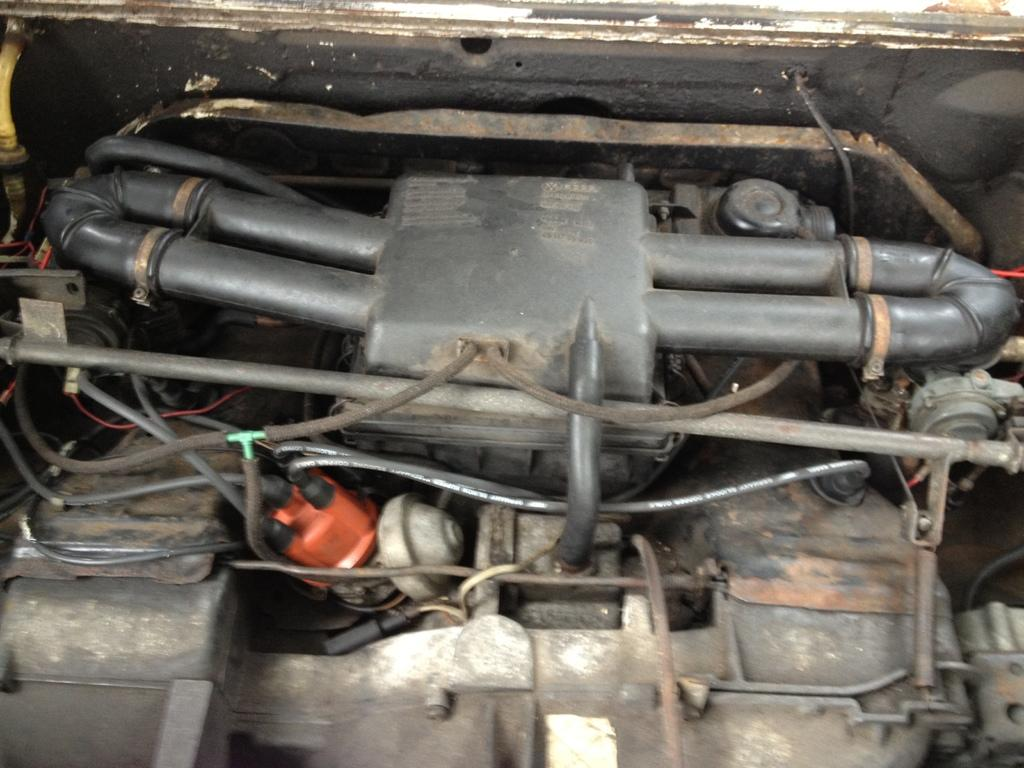What type of objects are featured in the image? The image contains machine parts of a car. Can you describe the specific parts that are visible in the image? Unfortunately, the provided facts do not specify which machine parts are visible in the image. What is the context or purpose of these machine parts? The context or purpose of these machine parts is not mentioned in the provided facts. What type of boat can be seen in the image? There is no boat present in the image; it features machine parts of a car. What kind of music is the band playing in the image? There is no band present in the image; it features machine parts of a car. 